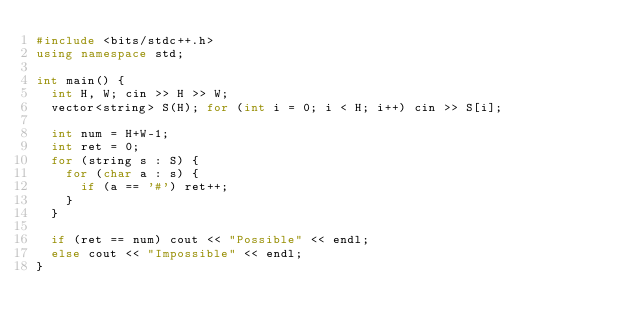Convert code to text. <code><loc_0><loc_0><loc_500><loc_500><_C++_>#include <bits/stdc++.h>
using namespace std;

int main() {
  int H, W; cin >> H >> W;
  vector<string> S(H); for (int i = 0; i < H; i++) cin >> S[i];
  
  int num = H+W-1;
  int ret = 0;
  for (string s : S) {
    for (char a : s) {
      if (a == '#') ret++;
    }
  }
  
  if (ret == num) cout << "Possible" << endl;
  else cout << "Impossible" << endl;
}
</code> 